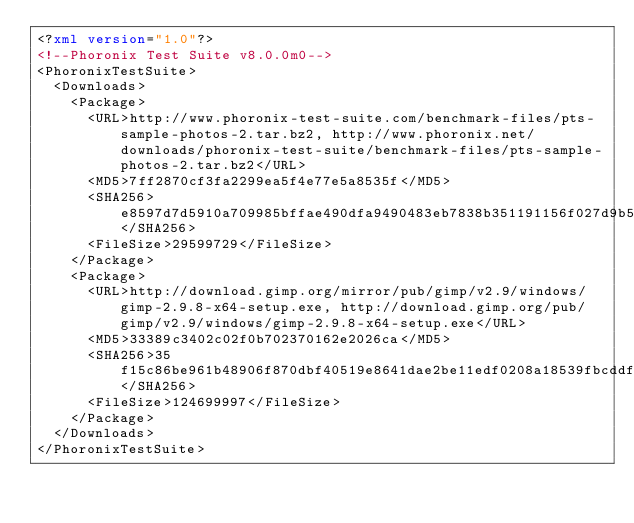<code> <loc_0><loc_0><loc_500><loc_500><_XML_><?xml version="1.0"?>
<!--Phoronix Test Suite v8.0.0m0-->
<PhoronixTestSuite>
  <Downloads>
    <Package>
      <URL>http://www.phoronix-test-suite.com/benchmark-files/pts-sample-photos-2.tar.bz2, http://www.phoronix.net/downloads/phoronix-test-suite/benchmark-files/pts-sample-photos-2.tar.bz2</URL>
      <MD5>7ff2870cf3fa2299ea5f4e77e5a8535f</MD5>
      <SHA256>e8597d7d5910a709985bffae490dfa9490483eb7838b351191156f027d9b5272</SHA256>
      <FileSize>29599729</FileSize>
    </Package>
    <Package>
      <URL>http://download.gimp.org/mirror/pub/gimp/v2.9/windows/gimp-2.9.8-x64-setup.exe, http://download.gimp.org/pub/gimp/v2.9/windows/gimp-2.9.8-x64-setup.exe</URL>
      <MD5>33389c3402c02f0b702370162e2026ca</MD5>
      <SHA256>35f15c86be961b48906f870dbf40519e8641dae2be11edf0208a18539fbcddfe</SHA256>
      <FileSize>124699997</FileSize>
    </Package>
  </Downloads>
</PhoronixTestSuite>
</code> 